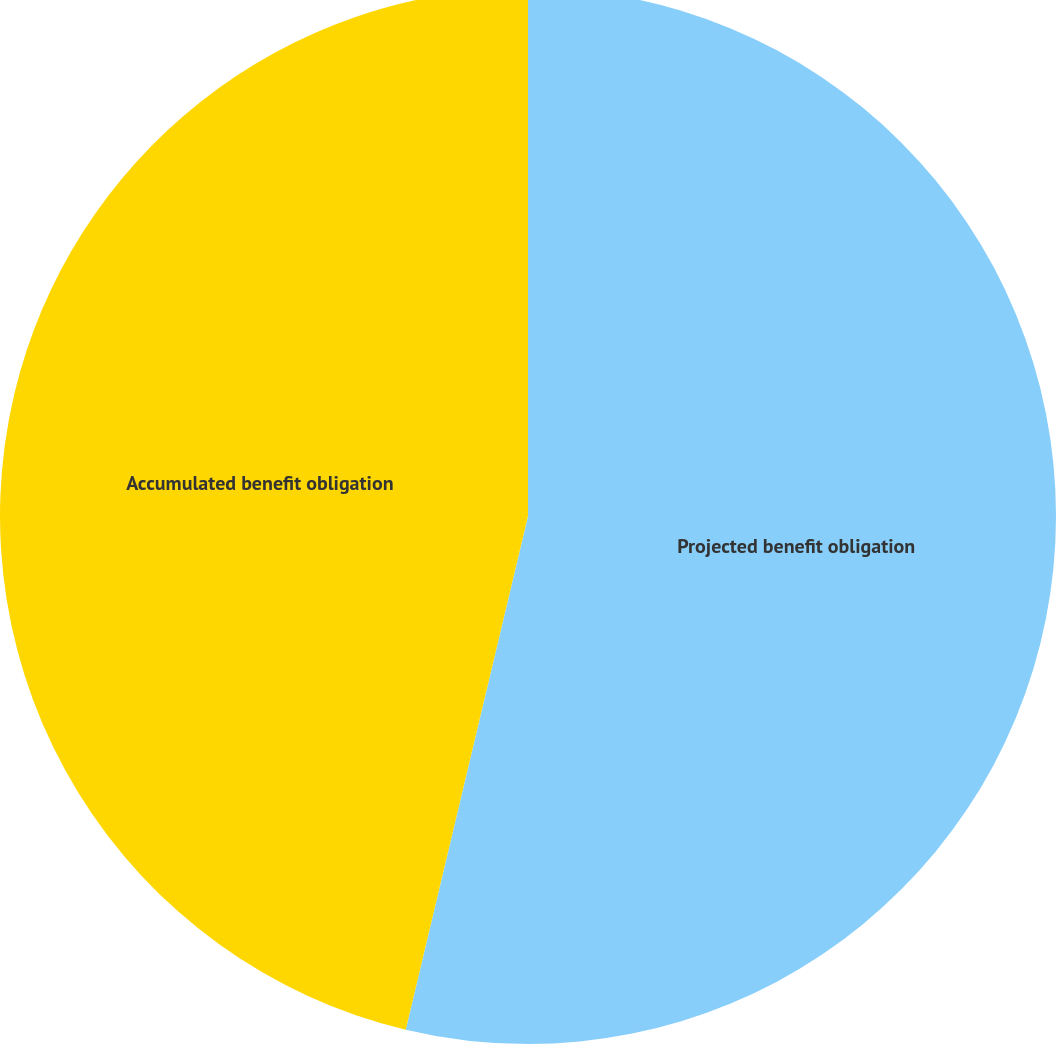Convert chart. <chart><loc_0><loc_0><loc_500><loc_500><pie_chart><fcel>Projected benefit obligation<fcel>Accumulated benefit obligation<nl><fcel>53.72%<fcel>46.28%<nl></chart> 